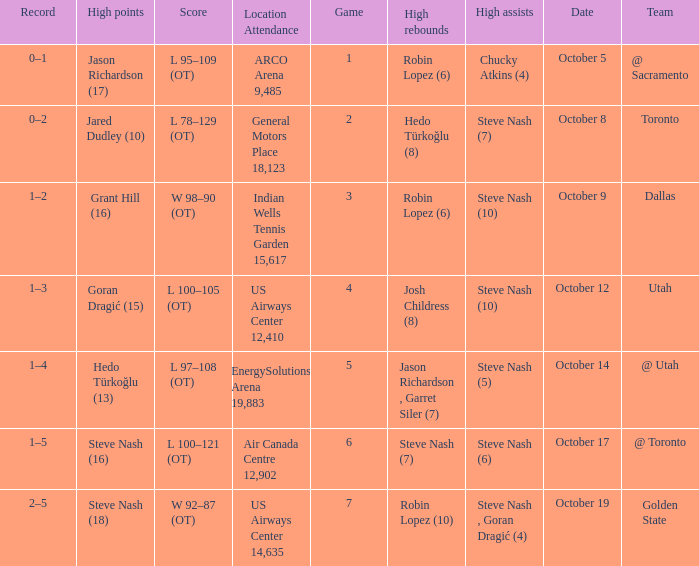Write the full table. {'header': ['Record', 'High points', 'Score', 'Location Attendance', 'Game', 'High rebounds', 'High assists', 'Date', 'Team'], 'rows': [['0–1', 'Jason Richardson (17)', 'L 95–109 (OT)', 'ARCO Arena 9,485', '1', 'Robin Lopez (6)', 'Chucky Atkins (4)', 'October 5', '@ Sacramento'], ['0–2', 'Jared Dudley (10)', 'L 78–129 (OT)', 'General Motors Place 18,123', '2', 'Hedo Türkoğlu (8)', 'Steve Nash (7)', 'October 8', 'Toronto'], ['1–2', 'Grant Hill (16)', 'W 98–90 (OT)', 'Indian Wells Tennis Garden 15,617', '3', 'Robin Lopez (6)', 'Steve Nash (10)', 'October 9', 'Dallas'], ['1–3', 'Goran Dragić (15)', 'L 100–105 (OT)', 'US Airways Center 12,410', '4', 'Josh Childress (8)', 'Steve Nash (10)', 'October 12', 'Utah'], ['1–4', 'Hedo Türkoğlu (13)', 'L 97–108 (OT)', 'EnergySolutions Arena 19,883', '5', 'Jason Richardson , Garret Siler (7)', 'Steve Nash (5)', 'October 14', '@ Utah'], ['1–5', 'Steve Nash (16)', 'L 100–121 (OT)', 'Air Canada Centre 12,902', '6', 'Steve Nash (7)', 'Steve Nash (6)', 'October 17', '@ Toronto'], ['2–5', 'Steve Nash (18)', 'W 92–87 (OT)', 'US Airways Center 14,635', '7', 'Robin Lopez (10)', 'Steve Nash , Goran Dragić (4)', 'October 19', 'Golden State']]} What two players had the highest rebounds for the October 14 game? Jason Richardson , Garret Siler (7). 